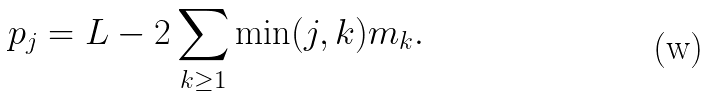Convert formula to latex. <formula><loc_0><loc_0><loc_500><loc_500>p _ { j } = L - 2 \sum _ { k \geq 1 } \min ( j , k ) m _ { k } .</formula> 